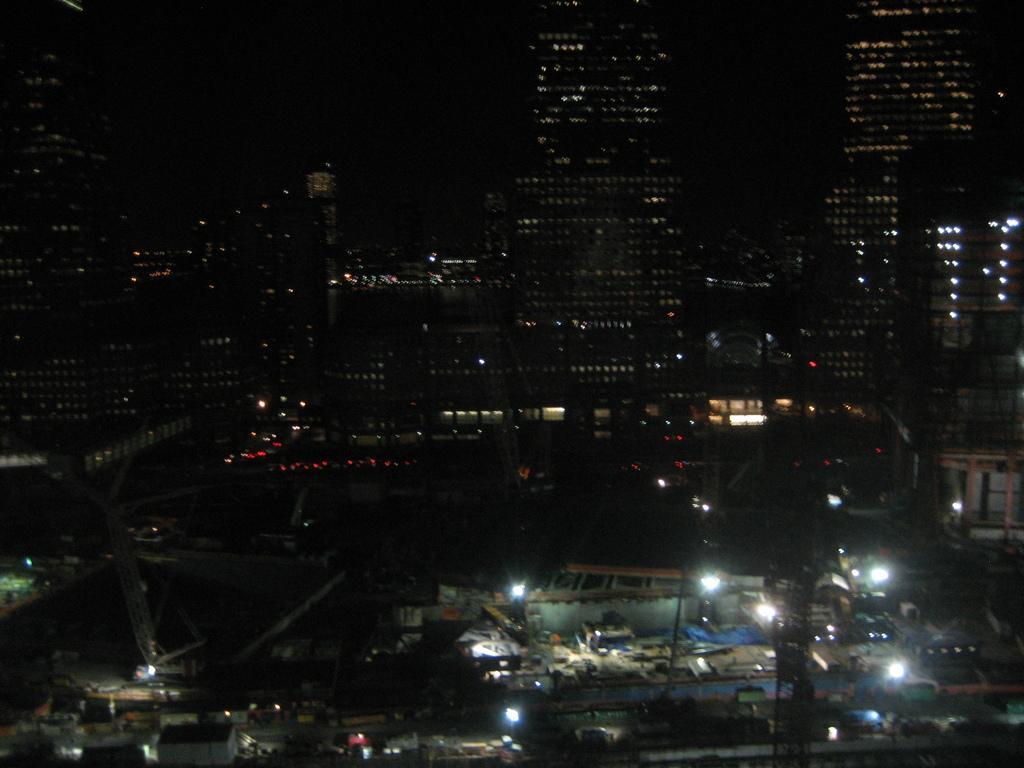How would you summarize this image in a sentence or two? In this picture we can see buildings, lights and some objects and in the background we can see it is dark. 